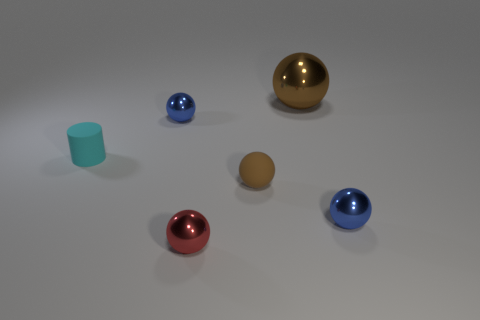Subtract 1 spheres. How many spheres are left? 4 Subtract all red spheres. How many spheres are left? 4 Subtract all purple spheres. Subtract all yellow cylinders. How many spheres are left? 5 Add 3 large purple matte spheres. How many objects exist? 9 Subtract all spheres. How many objects are left? 1 Subtract 0 yellow blocks. How many objects are left? 6 Subtract all small metallic objects. Subtract all tiny cylinders. How many objects are left? 2 Add 3 shiny balls. How many shiny balls are left? 7 Add 1 brown rubber spheres. How many brown rubber spheres exist? 2 